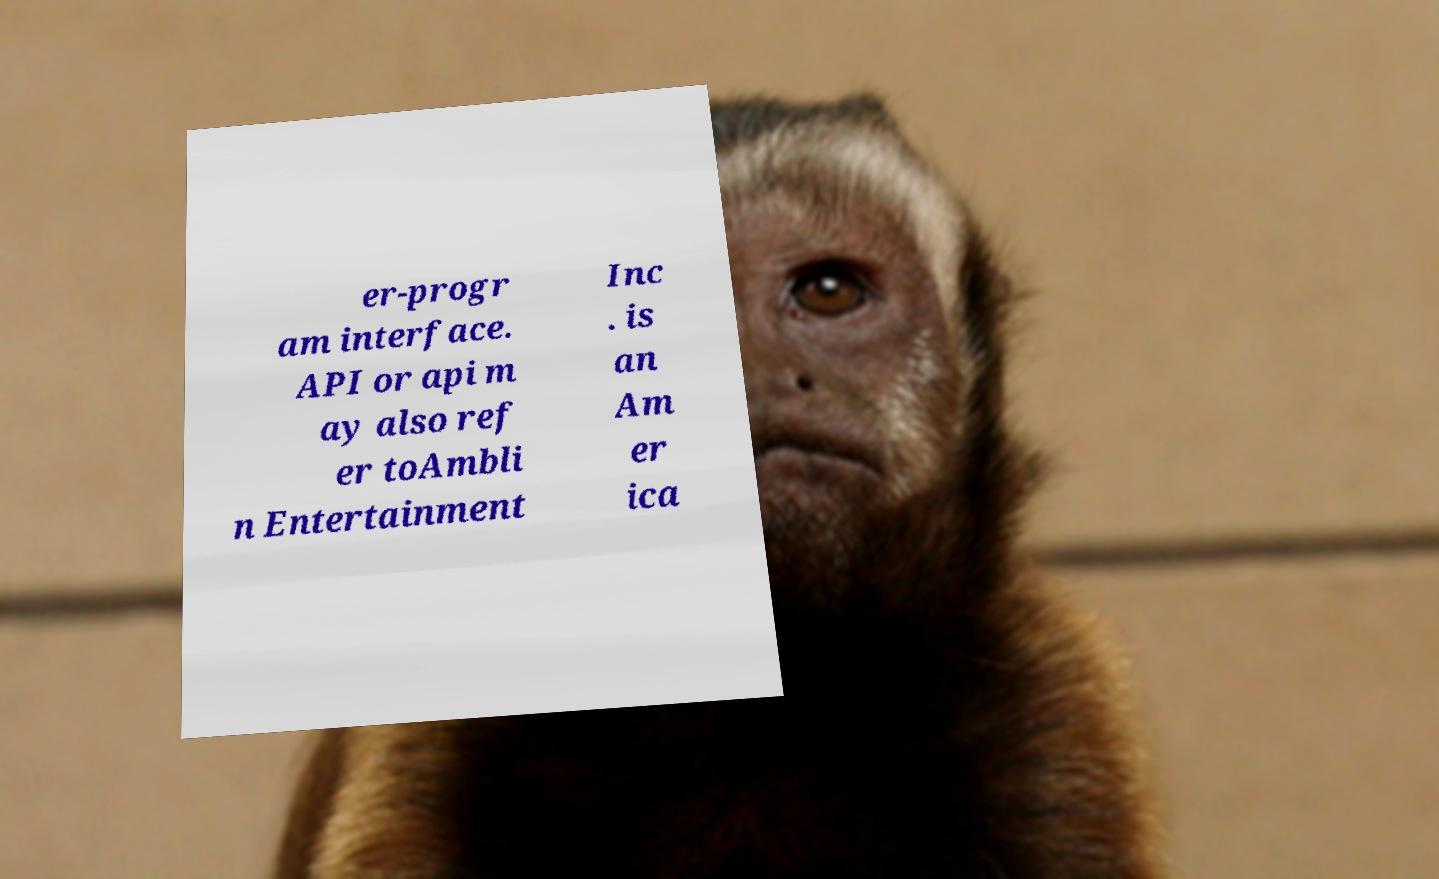Can you read and provide the text displayed in the image?This photo seems to have some interesting text. Can you extract and type it out for me? er-progr am interface. API or api m ay also ref er toAmbli n Entertainment Inc . is an Am er ica 